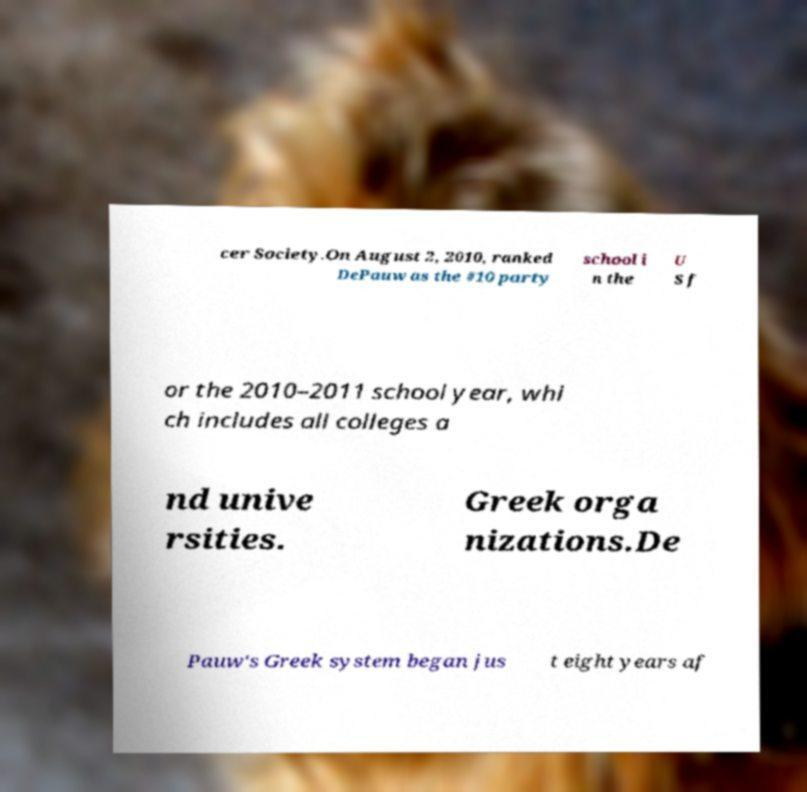Could you extract and type out the text from this image? cer Society.On August 2, 2010, ranked DePauw as the #10 party school i n the U S f or the 2010–2011 school year, whi ch includes all colleges a nd unive rsities. Greek orga nizations.De Pauw's Greek system began jus t eight years af 